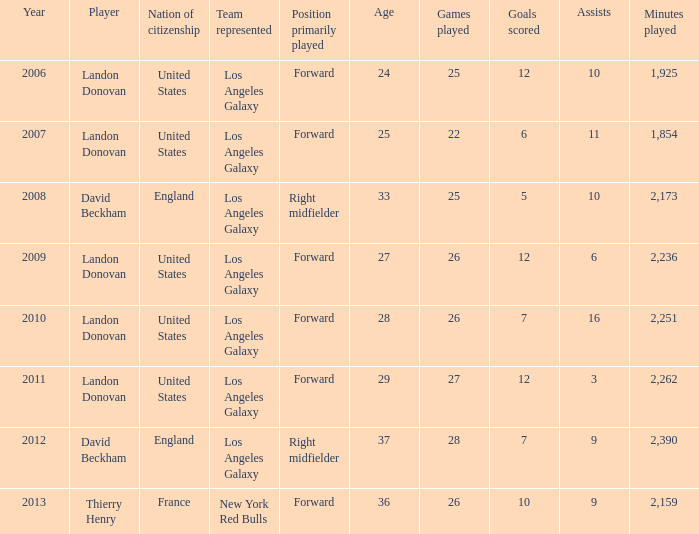What is the sum of all the years that Landon Donovan won the ESPY award? 5.0. 